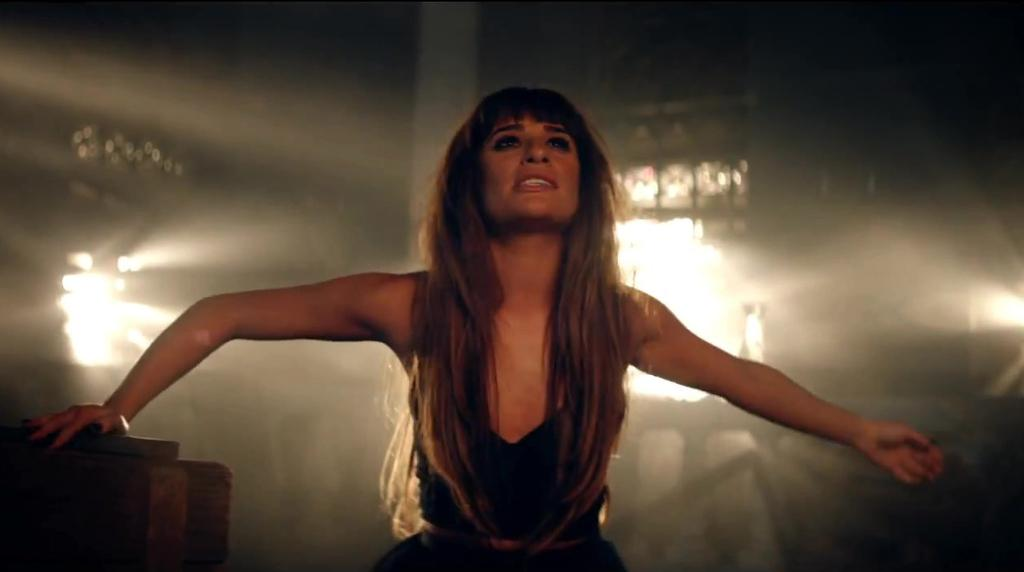What is the main subject of the image? There are women in the center of the image. What can be seen in the background of the image? There are lights and a wall in the background of the image. How many kittens can be seen climbing the wall in the image? There are no kittens present in the image; it features women in the center and lights and a wall in the background. 